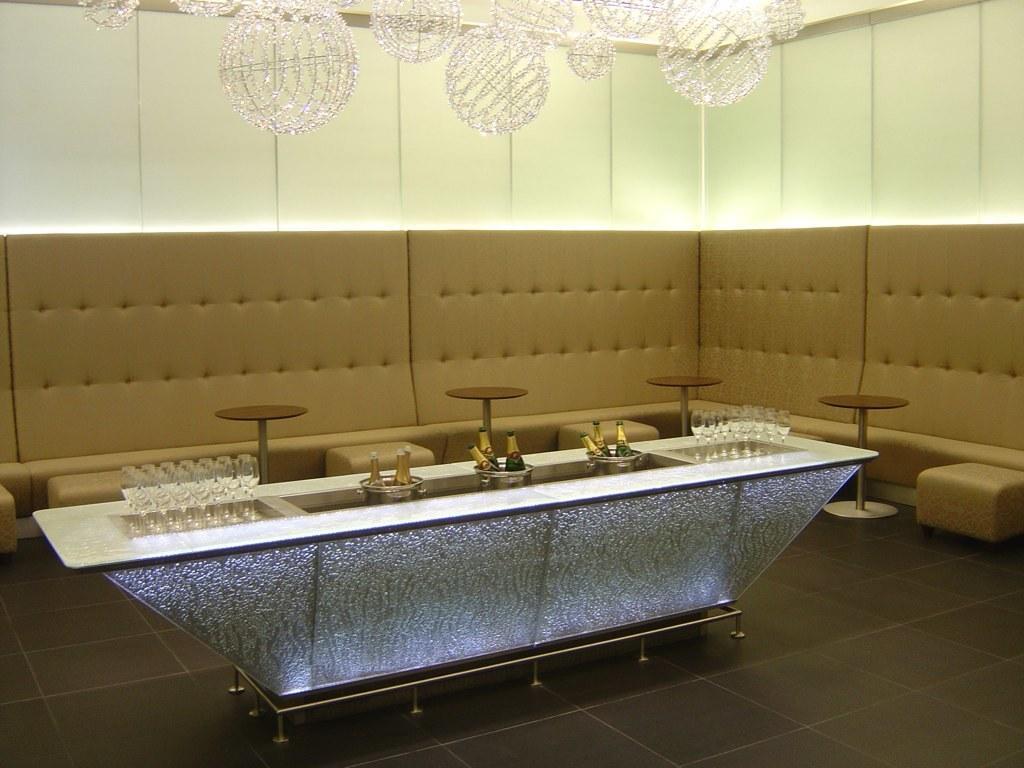How would you summarize this image in a sentence or two? This image consists of a sofa in brown color. In the middle, there is a table on which there are glasses and wine bottles. At the top, there are lights hanged. 